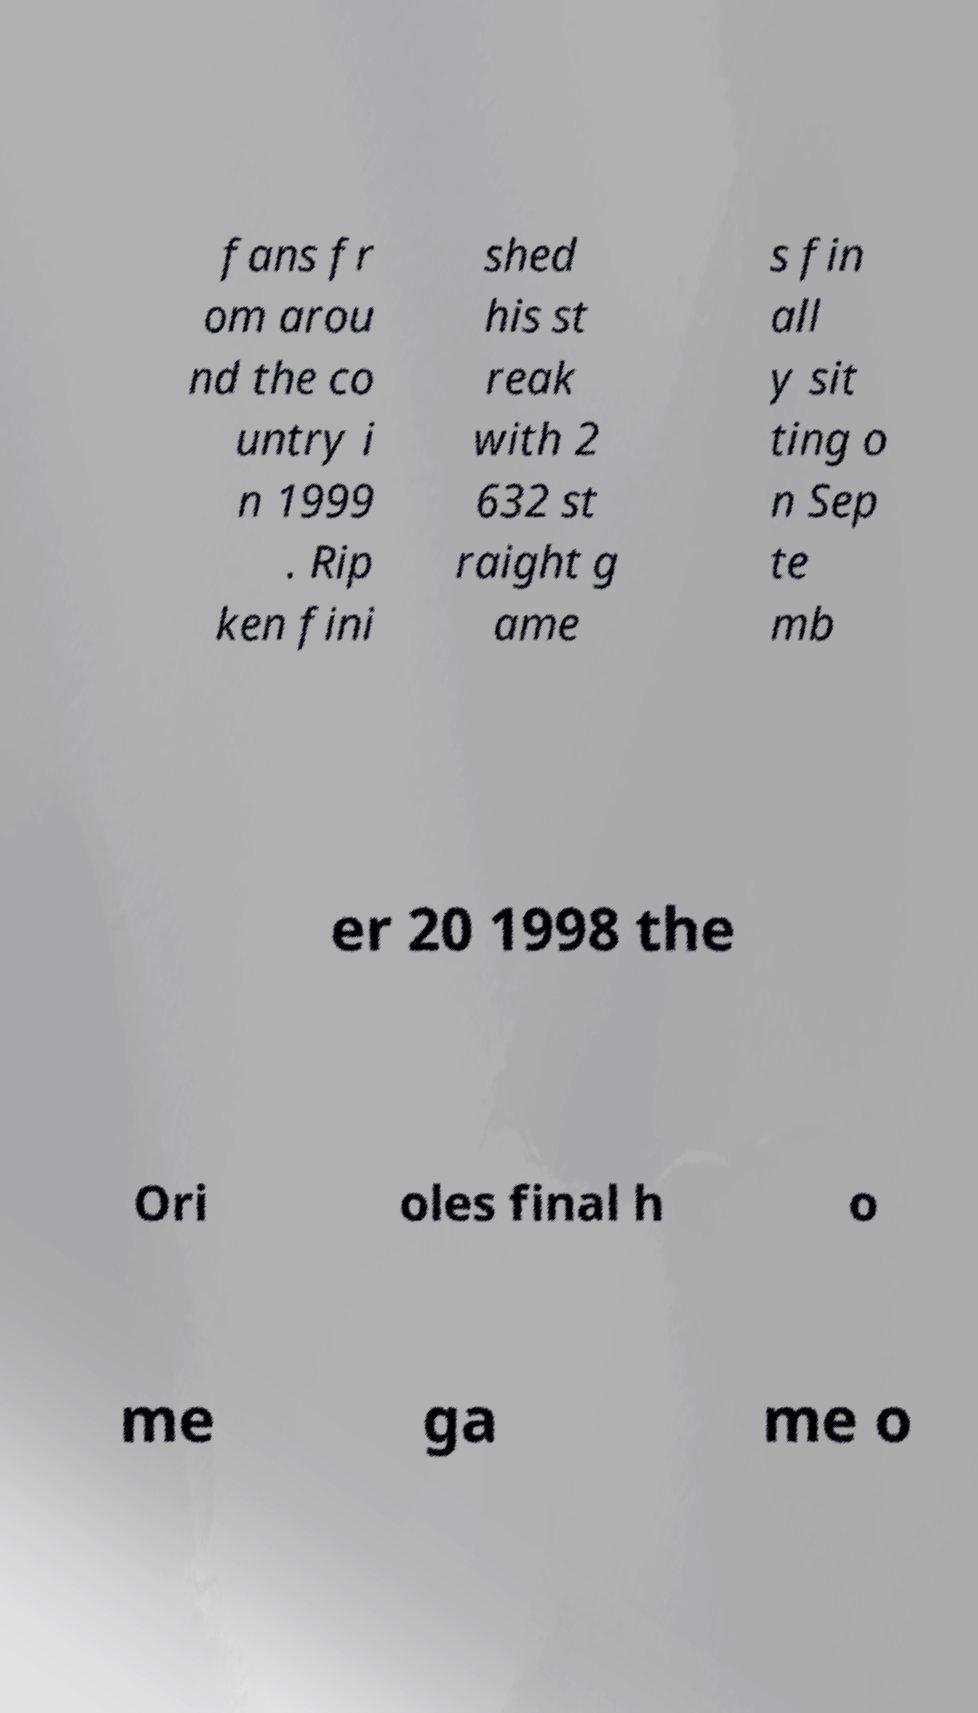Can you accurately transcribe the text from the provided image for me? fans fr om arou nd the co untry i n 1999 . Rip ken fini shed his st reak with 2 632 st raight g ame s fin all y sit ting o n Sep te mb er 20 1998 the Ori oles final h o me ga me o 